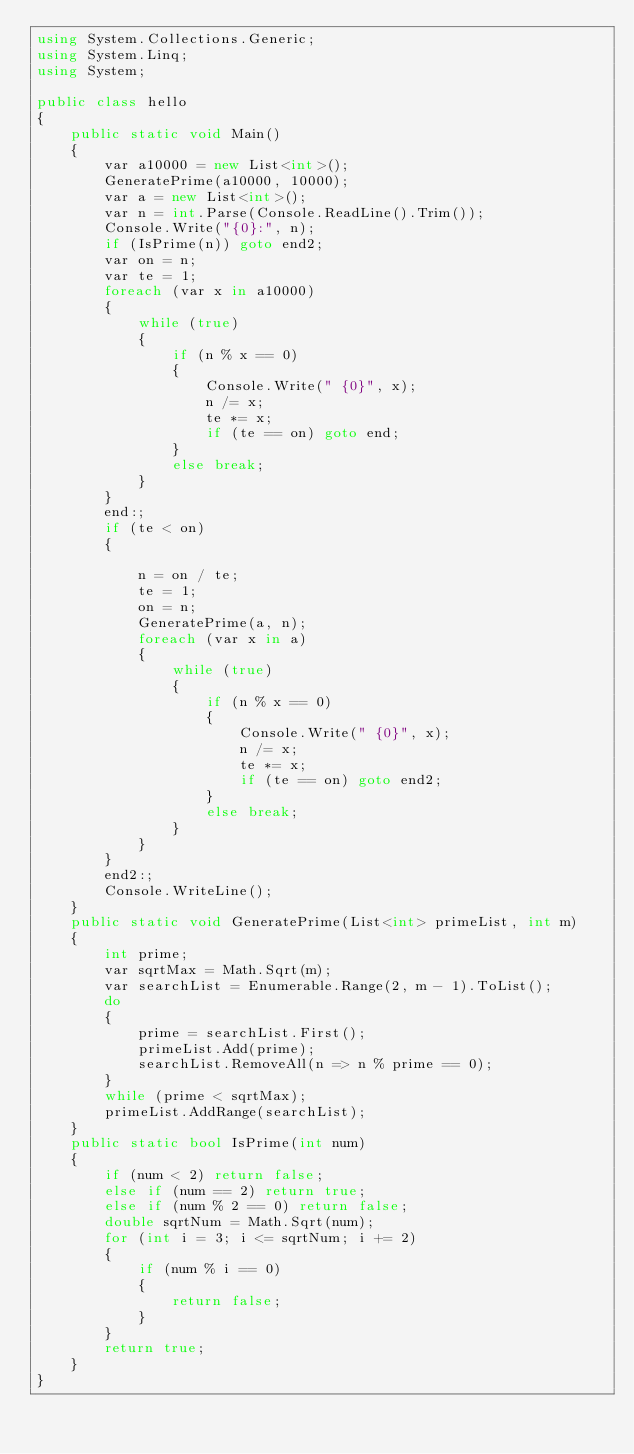<code> <loc_0><loc_0><loc_500><loc_500><_C#_>using System.Collections.Generic;
using System.Linq;
using System;

public class hello
{
    public static void Main()
    {
        var a10000 = new List<int>();
        GeneratePrime(a10000, 10000);
        var a = new List<int>();
        var n = int.Parse(Console.ReadLine().Trim());
        Console.Write("{0}:", n);
        if (IsPrime(n)) goto end2;
        var on = n;
        var te = 1;
        foreach (var x in a10000)
        {
            while (true)
            {
                if (n % x == 0)
                {
                    Console.Write(" {0}", x);
                    n /= x;
                    te *= x;
                    if (te == on) goto end;
                }
                else break;
            }
        }
        end:;
        if (te < on)
        {

            n = on / te;
            te = 1;
            on = n;
            GeneratePrime(a, n);
            foreach (var x in a)
            {
                while (true)
                {
                    if (n % x == 0)
                    {
                        Console.Write(" {0}", x);
                        n /= x;
                        te *= x;
                        if (te == on) goto end2;
                    }
                    else break;
                }
            }
        }
        end2:;
        Console.WriteLine();
    }
    public static void GeneratePrime(List<int> primeList, int m)
    {
        int prime;
        var sqrtMax = Math.Sqrt(m);
        var searchList = Enumerable.Range(2, m - 1).ToList();
        do
        {
            prime = searchList.First();
            primeList.Add(prime);
            searchList.RemoveAll(n => n % prime == 0);
        }
        while (prime < sqrtMax);
        primeList.AddRange(searchList);
    }
    public static bool IsPrime(int num)
    {
        if (num < 2) return false;
        else if (num == 2) return true;
        else if (num % 2 == 0) return false; 
        double sqrtNum = Math.Sqrt(num);
        for (int i = 3; i <= sqrtNum; i += 2)
        {
            if (num % i == 0)
            {
                return false;
            }
        }
        return true;
    }
}</code> 